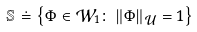<formula> <loc_0><loc_0><loc_500><loc_500>\mathbb { S } \doteq \left \{ \Phi \in \mathcal { W } _ { 1 } \colon \left \| \Phi \right \| _ { \mathcal { U } } = 1 \right \}</formula> 